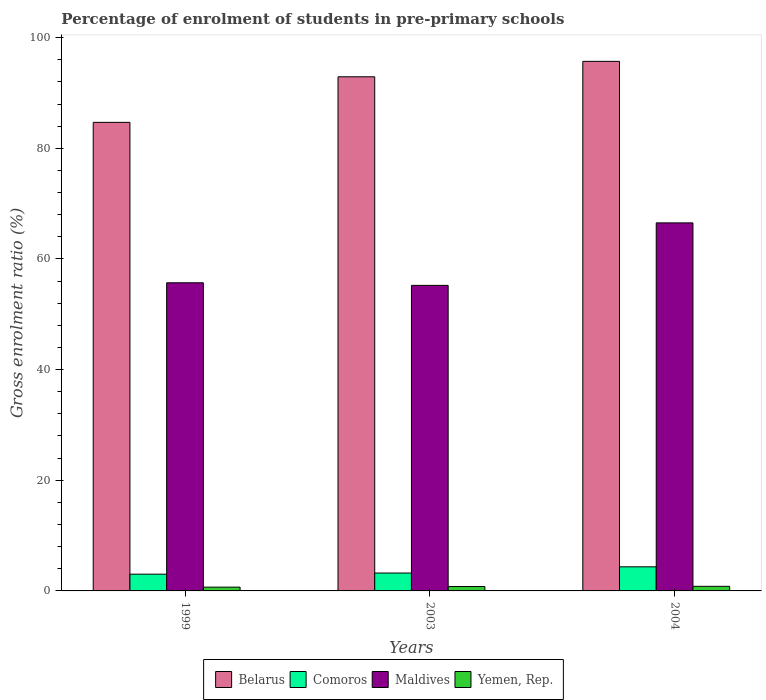How many groups of bars are there?
Provide a succinct answer. 3. Are the number of bars per tick equal to the number of legend labels?
Your answer should be very brief. Yes. Are the number of bars on each tick of the X-axis equal?
Give a very brief answer. Yes. In how many cases, is the number of bars for a given year not equal to the number of legend labels?
Keep it short and to the point. 0. What is the percentage of students enrolled in pre-primary schools in Yemen, Rep. in 2003?
Your response must be concise. 0.8. Across all years, what is the maximum percentage of students enrolled in pre-primary schools in Yemen, Rep.?
Keep it short and to the point. 0.83. Across all years, what is the minimum percentage of students enrolled in pre-primary schools in Belarus?
Offer a very short reply. 84.68. In which year was the percentage of students enrolled in pre-primary schools in Maldives maximum?
Offer a terse response. 2004. In which year was the percentage of students enrolled in pre-primary schools in Belarus minimum?
Your answer should be compact. 1999. What is the total percentage of students enrolled in pre-primary schools in Maldives in the graph?
Ensure brevity in your answer.  177.43. What is the difference between the percentage of students enrolled in pre-primary schools in Yemen, Rep. in 2003 and that in 2004?
Make the answer very short. -0.03. What is the difference between the percentage of students enrolled in pre-primary schools in Yemen, Rep. in 2003 and the percentage of students enrolled in pre-primary schools in Maldives in 2004?
Provide a succinct answer. -65.72. What is the average percentage of students enrolled in pre-primary schools in Belarus per year?
Your answer should be very brief. 91.1. In the year 1999, what is the difference between the percentage of students enrolled in pre-primary schools in Comoros and percentage of students enrolled in pre-primary schools in Yemen, Rep.?
Provide a succinct answer. 2.35. In how many years, is the percentage of students enrolled in pre-primary schools in Maldives greater than 76 %?
Keep it short and to the point. 0. What is the ratio of the percentage of students enrolled in pre-primary schools in Belarus in 1999 to that in 2003?
Provide a short and direct response. 0.91. Is the difference between the percentage of students enrolled in pre-primary schools in Comoros in 1999 and 2003 greater than the difference between the percentage of students enrolled in pre-primary schools in Yemen, Rep. in 1999 and 2003?
Ensure brevity in your answer.  No. What is the difference between the highest and the second highest percentage of students enrolled in pre-primary schools in Maldives?
Provide a succinct answer. 10.82. What is the difference between the highest and the lowest percentage of students enrolled in pre-primary schools in Yemen, Rep.?
Ensure brevity in your answer.  0.15. Is the sum of the percentage of students enrolled in pre-primary schools in Maldives in 2003 and 2004 greater than the maximum percentage of students enrolled in pre-primary schools in Yemen, Rep. across all years?
Your answer should be compact. Yes. Is it the case that in every year, the sum of the percentage of students enrolled in pre-primary schools in Belarus and percentage of students enrolled in pre-primary schools in Maldives is greater than the sum of percentage of students enrolled in pre-primary schools in Yemen, Rep. and percentage of students enrolled in pre-primary schools in Comoros?
Offer a terse response. Yes. What does the 1st bar from the left in 2003 represents?
Provide a short and direct response. Belarus. What does the 3rd bar from the right in 2003 represents?
Provide a succinct answer. Comoros. Is it the case that in every year, the sum of the percentage of students enrolled in pre-primary schools in Yemen, Rep. and percentage of students enrolled in pre-primary schools in Maldives is greater than the percentage of students enrolled in pre-primary schools in Belarus?
Provide a succinct answer. No. How many bars are there?
Make the answer very short. 12. How many years are there in the graph?
Give a very brief answer. 3. What is the difference between two consecutive major ticks on the Y-axis?
Keep it short and to the point. 20. Does the graph contain any zero values?
Your response must be concise. No. Where does the legend appear in the graph?
Give a very brief answer. Bottom center. How many legend labels are there?
Your response must be concise. 4. How are the legend labels stacked?
Keep it short and to the point. Horizontal. What is the title of the graph?
Give a very brief answer. Percentage of enrolment of students in pre-primary schools. Does "South Asia" appear as one of the legend labels in the graph?
Your response must be concise. No. What is the Gross enrolment ratio (%) of Belarus in 1999?
Your response must be concise. 84.68. What is the Gross enrolment ratio (%) of Comoros in 1999?
Keep it short and to the point. 3.03. What is the Gross enrolment ratio (%) of Maldives in 1999?
Provide a succinct answer. 55.69. What is the Gross enrolment ratio (%) in Yemen, Rep. in 1999?
Your answer should be very brief. 0.68. What is the Gross enrolment ratio (%) in Belarus in 2003?
Keep it short and to the point. 92.92. What is the Gross enrolment ratio (%) of Comoros in 2003?
Your answer should be compact. 3.23. What is the Gross enrolment ratio (%) of Maldives in 2003?
Give a very brief answer. 55.22. What is the Gross enrolment ratio (%) in Yemen, Rep. in 2003?
Offer a terse response. 0.8. What is the Gross enrolment ratio (%) of Belarus in 2004?
Your answer should be compact. 95.71. What is the Gross enrolment ratio (%) of Comoros in 2004?
Make the answer very short. 4.36. What is the Gross enrolment ratio (%) in Maldives in 2004?
Your answer should be compact. 66.52. What is the Gross enrolment ratio (%) of Yemen, Rep. in 2004?
Your response must be concise. 0.83. Across all years, what is the maximum Gross enrolment ratio (%) in Belarus?
Your answer should be very brief. 95.71. Across all years, what is the maximum Gross enrolment ratio (%) of Comoros?
Keep it short and to the point. 4.36. Across all years, what is the maximum Gross enrolment ratio (%) in Maldives?
Give a very brief answer. 66.52. Across all years, what is the maximum Gross enrolment ratio (%) of Yemen, Rep.?
Make the answer very short. 0.83. Across all years, what is the minimum Gross enrolment ratio (%) of Belarus?
Keep it short and to the point. 84.68. Across all years, what is the minimum Gross enrolment ratio (%) in Comoros?
Your response must be concise. 3.03. Across all years, what is the minimum Gross enrolment ratio (%) in Maldives?
Provide a succinct answer. 55.22. Across all years, what is the minimum Gross enrolment ratio (%) of Yemen, Rep.?
Your answer should be very brief. 0.68. What is the total Gross enrolment ratio (%) in Belarus in the graph?
Your answer should be very brief. 273.31. What is the total Gross enrolment ratio (%) in Comoros in the graph?
Offer a terse response. 10.62. What is the total Gross enrolment ratio (%) in Maldives in the graph?
Your response must be concise. 177.43. What is the total Gross enrolment ratio (%) of Yemen, Rep. in the graph?
Provide a short and direct response. 2.3. What is the difference between the Gross enrolment ratio (%) in Belarus in 1999 and that in 2003?
Make the answer very short. -8.23. What is the difference between the Gross enrolment ratio (%) in Comoros in 1999 and that in 2003?
Provide a short and direct response. -0.2. What is the difference between the Gross enrolment ratio (%) of Maldives in 1999 and that in 2003?
Your answer should be very brief. 0.47. What is the difference between the Gross enrolment ratio (%) of Yemen, Rep. in 1999 and that in 2003?
Your answer should be compact. -0.11. What is the difference between the Gross enrolment ratio (%) in Belarus in 1999 and that in 2004?
Make the answer very short. -11.02. What is the difference between the Gross enrolment ratio (%) in Comoros in 1999 and that in 2004?
Your answer should be compact. -1.33. What is the difference between the Gross enrolment ratio (%) in Maldives in 1999 and that in 2004?
Make the answer very short. -10.82. What is the difference between the Gross enrolment ratio (%) of Yemen, Rep. in 1999 and that in 2004?
Provide a succinct answer. -0.15. What is the difference between the Gross enrolment ratio (%) of Belarus in 2003 and that in 2004?
Offer a terse response. -2.79. What is the difference between the Gross enrolment ratio (%) in Comoros in 2003 and that in 2004?
Ensure brevity in your answer.  -1.12. What is the difference between the Gross enrolment ratio (%) of Maldives in 2003 and that in 2004?
Make the answer very short. -11.3. What is the difference between the Gross enrolment ratio (%) in Yemen, Rep. in 2003 and that in 2004?
Give a very brief answer. -0.03. What is the difference between the Gross enrolment ratio (%) of Belarus in 1999 and the Gross enrolment ratio (%) of Comoros in 2003?
Your answer should be very brief. 81.45. What is the difference between the Gross enrolment ratio (%) of Belarus in 1999 and the Gross enrolment ratio (%) of Maldives in 2003?
Your answer should be very brief. 29.47. What is the difference between the Gross enrolment ratio (%) of Belarus in 1999 and the Gross enrolment ratio (%) of Yemen, Rep. in 2003?
Keep it short and to the point. 83.89. What is the difference between the Gross enrolment ratio (%) of Comoros in 1999 and the Gross enrolment ratio (%) of Maldives in 2003?
Your answer should be compact. -52.19. What is the difference between the Gross enrolment ratio (%) of Comoros in 1999 and the Gross enrolment ratio (%) of Yemen, Rep. in 2003?
Your response must be concise. 2.23. What is the difference between the Gross enrolment ratio (%) of Maldives in 1999 and the Gross enrolment ratio (%) of Yemen, Rep. in 2003?
Provide a succinct answer. 54.9. What is the difference between the Gross enrolment ratio (%) of Belarus in 1999 and the Gross enrolment ratio (%) of Comoros in 2004?
Make the answer very short. 80.33. What is the difference between the Gross enrolment ratio (%) in Belarus in 1999 and the Gross enrolment ratio (%) in Maldives in 2004?
Your response must be concise. 18.17. What is the difference between the Gross enrolment ratio (%) in Belarus in 1999 and the Gross enrolment ratio (%) in Yemen, Rep. in 2004?
Keep it short and to the point. 83.86. What is the difference between the Gross enrolment ratio (%) of Comoros in 1999 and the Gross enrolment ratio (%) of Maldives in 2004?
Make the answer very short. -63.49. What is the difference between the Gross enrolment ratio (%) of Comoros in 1999 and the Gross enrolment ratio (%) of Yemen, Rep. in 2004?
Offer a very short reply. 2.2. What is the difference between the Gross enrolment ratio (%) in Maldives in 1999 and the Gross enrolment ratio (%) in Yemen, Rep. in 2004?
Give a very brief answer. 54.86. What is the difference between the Gross enrolment ratio (%) of Belarus in 2003 and the Gross enrolment ratio (%) of Comoros in 2004?
Ensure brevity in your answer.  88.56. What is the difference between the Gross enrolment ratio (%) in Belarus in 2003 and the Gross enrolment ratio (%) in Maldives in 2004?
Offer a very short reply. 26.4. What is the difference between the Gross enrolment ratio (%) in Belarus in 2003 and the Gross enrolment ratio (%) in Yemen, Rep. in 2004?
Provide a short and direct response. 92.09. What is the difference between the Gross enrolment ratio (%) of Comoros in 2003 and the Gross enrolment ratio (%) of Maldives in 2004?
Offer a terse response. -63.28. What is the difference between the Gross enrolment ratio (%) of Comoros in 2003 and the Gross enrolment ratio (%) of Yemen, Rep. in 2004?
Provide a succinct answer. 2.4. What is the difference between the Gross enrolment ratio (%) of Maldives in 2003 and the Gross enrolment ratio (%) of Yemen, Rep. in 2004?
Give a very brief answer. 54.39. What is the average Gross enrolment ratio (%) in Belarus per year?
Keep it short and to the point. 91.1. What is the average Gross enrolment ratio (%) in Comoros per year?
Your answer should be compact. 3.54. What is the average Gross enrolment ratio (%) of Maldives per year?
Your response must be concise. 59.14. What is the average Gross enrolment ratio (%) in Yemen, Rep. per year?
Give a very brief answer. 0.77. In the year 1999, what is the difference between the Gross enrolment ratio (%) of Belarus and Gross enrolment ratio (%) of Comoros?
Ensure brevity in your answer.  81.66. In the year 1999, what is the difference between the Gross enrolment ratio (%) of Belarus and Gross enrolment ratio (%) of Maldives?
Make the answer very short. 28.99. In the year 1999, what is the difference between the Gross enrolment ratio (%) of Belarus and Gross enrolment ratio (%) of Yemen, Rep.?
Provide a short and direct response. 84. In the year 1999, what is the difference between the Gross enrolment ratio (%) of Comoros and Gross enrolment ratio (%) of Maldives?
Make the answer very short. -52.66. In the year 1999, what is the difference between the Gross enrolment ratio (%) of Comoros and Gross enrolment ratio (%) of Yemen, Rep.?
Keep it short and to the point. 2.35. In the year 1999, what is the difference between the Gross enrolment ratio (%) in Maldives and Gross enrolment ratio (%) in Yemen, Rep.?
Keep it short and to the point. 55.01. In the year 2003, what is the difference between the Gross enrolment ratio (%) in Belarus and Gross enrolment ratio (%) in Comoros?
Keep it short and to the point. 89.69. In the year 2003, what is the difference between the Gross enrolment ratio (%) in Belarus and Gross enrolment ratio (%) in Maldives?
Offer a terse response. 37.7. In the year 2003, what is the difference between the Gross enrolment ratio (%) of Belarus and Gross enrolment ratio (%) of Yemen, Rep.?
Make the answer very short. 92.12. In the year 2003, what is the difference between the Gross enrolment ratio (%) of Comoros and Gross enrolment ratio (%) of Maldives?
Offer a very short reply. -51.99. In the year 2003, what is the difference between the Gross enrolment ratio (%) of Comoros and Gross enrolment ratio (%) of Yemen, Rep.?
Keep it short and to the point. 2.44. In the year 2003, what is the difference between the Gross enrolment ratio (%) of Maldives and Gross enrolment ratio (%) of Yemen, Rep.?
Your answer should be compact. 54.42. In the year 2004, what is the difference between the Gross enrolment ratio (%) of Belarus and Gross enrolment ratio (%) of Comoros?
Make the answer very short. 91.35. In the year 2004, what is the difference between the Gross enrolment ratio (%) in Belarus and Gross enrolment ratio (%) in Maldives?
Provide a succinct answer. 29.19. In the year 2004, what is the difference between the Gross enrolment ratio (%) in Belarus and Gross enrolment ratio (%) in Yemen, Rep.?
Provide a succinct answer. 94.88. In the year 2004, what is the difference between the Gross enrolment ratio (%) of Comoros and Gross enrolment ratio (%) of Maldives?
Offer a terse response. -62.16. In the year 2004, what is the difference between the Gross enrolment ratio (%) in Comoros and Gross enrolment ratio (%) in Yemen, Rep.?
Ensure brevity in your answer.  3.53. In the year 2004, what is the difference between the Gross enrolment ratio (%) in Maldives and Gross enrolment ratio (%) in Yemen, Rep.?
Your answer should be compact. 65.69. What is the ratio of the Gross enrolment ratio (%) of Belarus in 1999 to that in 2003?
Give a very brief answer. 0.91. What is the ratio of the Gross enrolment ratio (%) of Comoros in 1999 to that in 2003?
Make the answer very short. 0.94. What is the ratio of the Gross enrolment ratio (%) in Maldives in 1999 to that in 2003?
Give a very brief answer. 1.01. What is the ratio of the Gross enrolment ratio (%) of Yemen, Rep. in 1999 to that in 2003?
Your answer should be very brief. 0.86. What is the ratio of the Gross enrolment ratio (%) in Belarus in 1999 to that in 2004?
Your answer should be very brief. 0.88. What is the ratio of the Gross enrolment ratio (%) in Comoros in 1999 to that in 2004?
Provide a succinct answer. 0.7. What is the ratio of the Gross enrolment ratio (%) of Maldives in 1999 to that in 2004?
Your answer should be very brief. 0.84. What is the ratio of the Gross enrolment ratio (%) in Yemen, Rep. in 1999 to that in 2004?
Keep it short and to the point. 0.82. What is the ratio of the Gross enrolment ratio (%) of Belarus in 2003 to that in 2004?
Your answer should be compact. 0.97. What is the ratio of the Gross enrolment ratio (%) in Comoros in 2003 to that in 2004?
Keep it short and to the point. 0.74. What is the ratio of the Gross enrolment ratio (%) of Maldives in 2003 to that in 2004?
Offer a very short reply. 0.83. What is the ratio of the Gross enrolment ratio (%) in Yemen, Rep. in 2003 to that in 2004?
Provide a succinct answer. 0.96. What is the difference between the highest and the second highest Gross enrolment ratio (%) of Belarus?
Your answer should be compact. 2.79. What is the difference between the highest and the second highest Gross enrolment ratio (%) in Comoros?
Your answer should be very brief. 1.12. What is the difference between the highest and the second highest Gross enrolment ratio (%) in Maldives?
Offer a very short reply. 10.82. What is the difference between the highest and the second highest Gross enrolment ratio (%) in Yemen, Rep.?
Provide a succinct answer. 0.03. What is the difference between the highest and the lowest Gross enrolment ratio (%) of Belarus?
Offer a terse response. 11.02. What is the difference between the highest and the lowest Gross enrolment ratio (%) in Comoros?
Your response must be concise. 1.33. What is the difference between the highest and the lowest Gross enrolment ratio (%) in Maldives?
Your response must be concise. 11.3. What is the difference between the highest and the lowest Gross enrolment ratio (%) in Yemen, Rep.?
Your answer should be very brief. 0.15. 